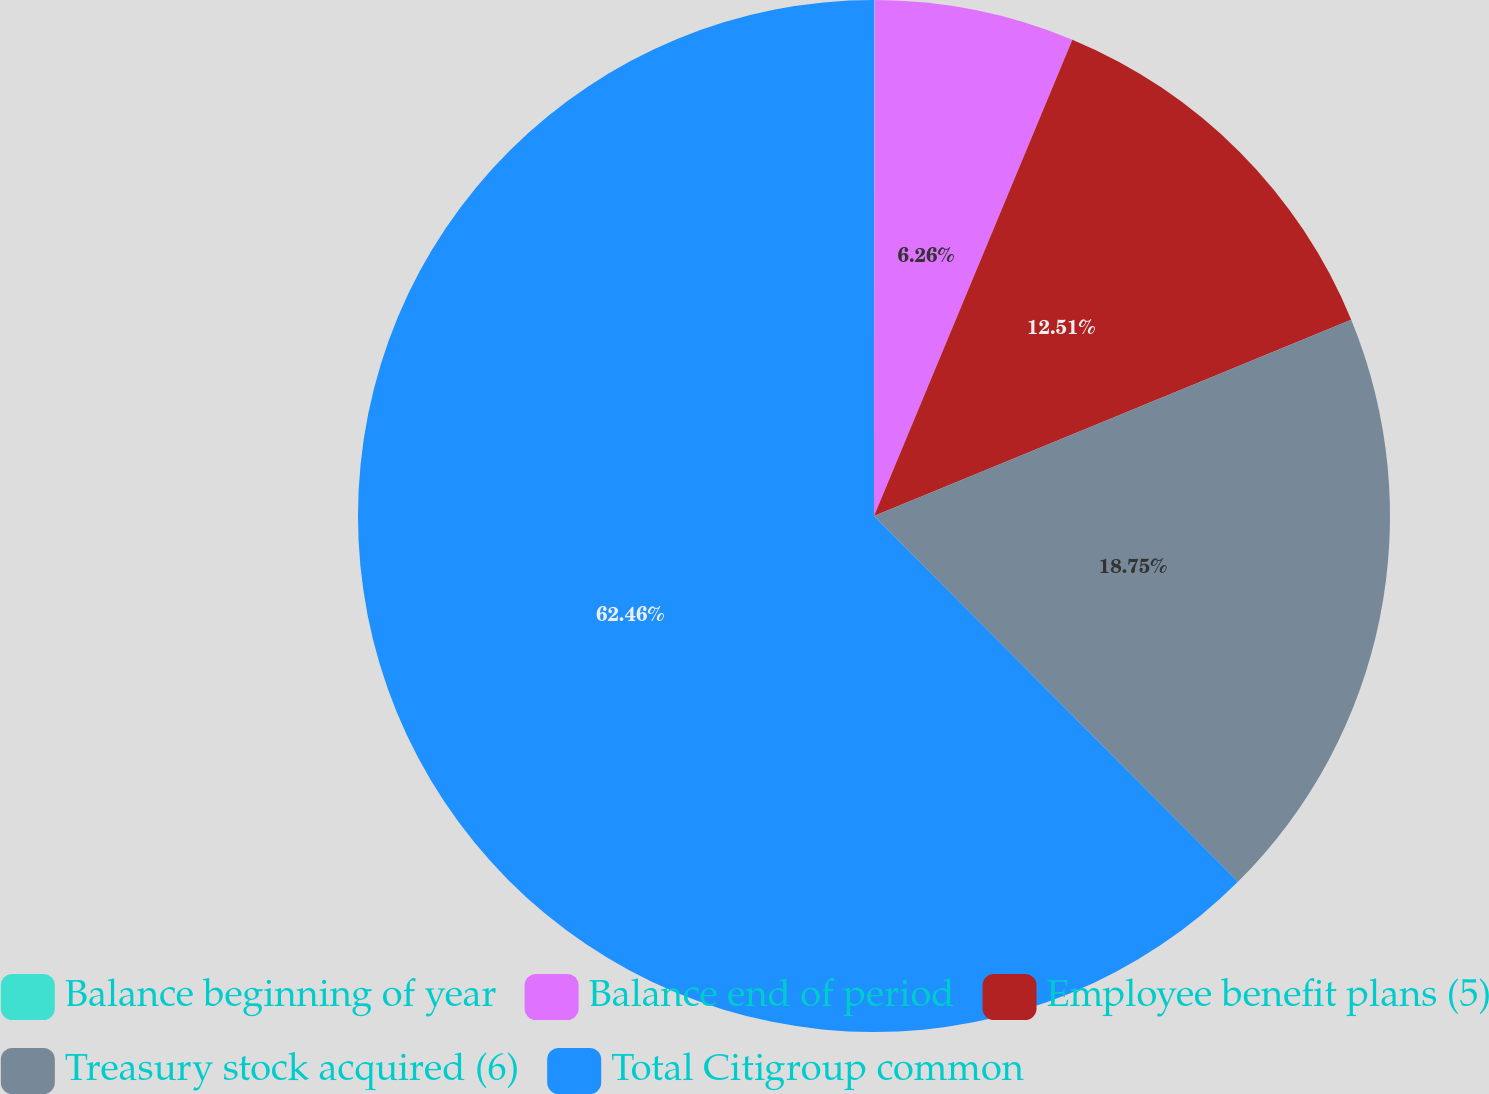<chart> <loc_0><loc_0><loc_500><loc_500><pie_chart><fcel>Balance beginning of year<fcel>Balance end of period<fcel>Employee benefit plans (5)<fcel>Treasury stock acquired (6)<fcel>Total Citigroup common<nl><fcel>0.02%<fcel>6.26%<fcel>12.51%<fcel>18.75%<fcel>62.46%<nl></chart> 